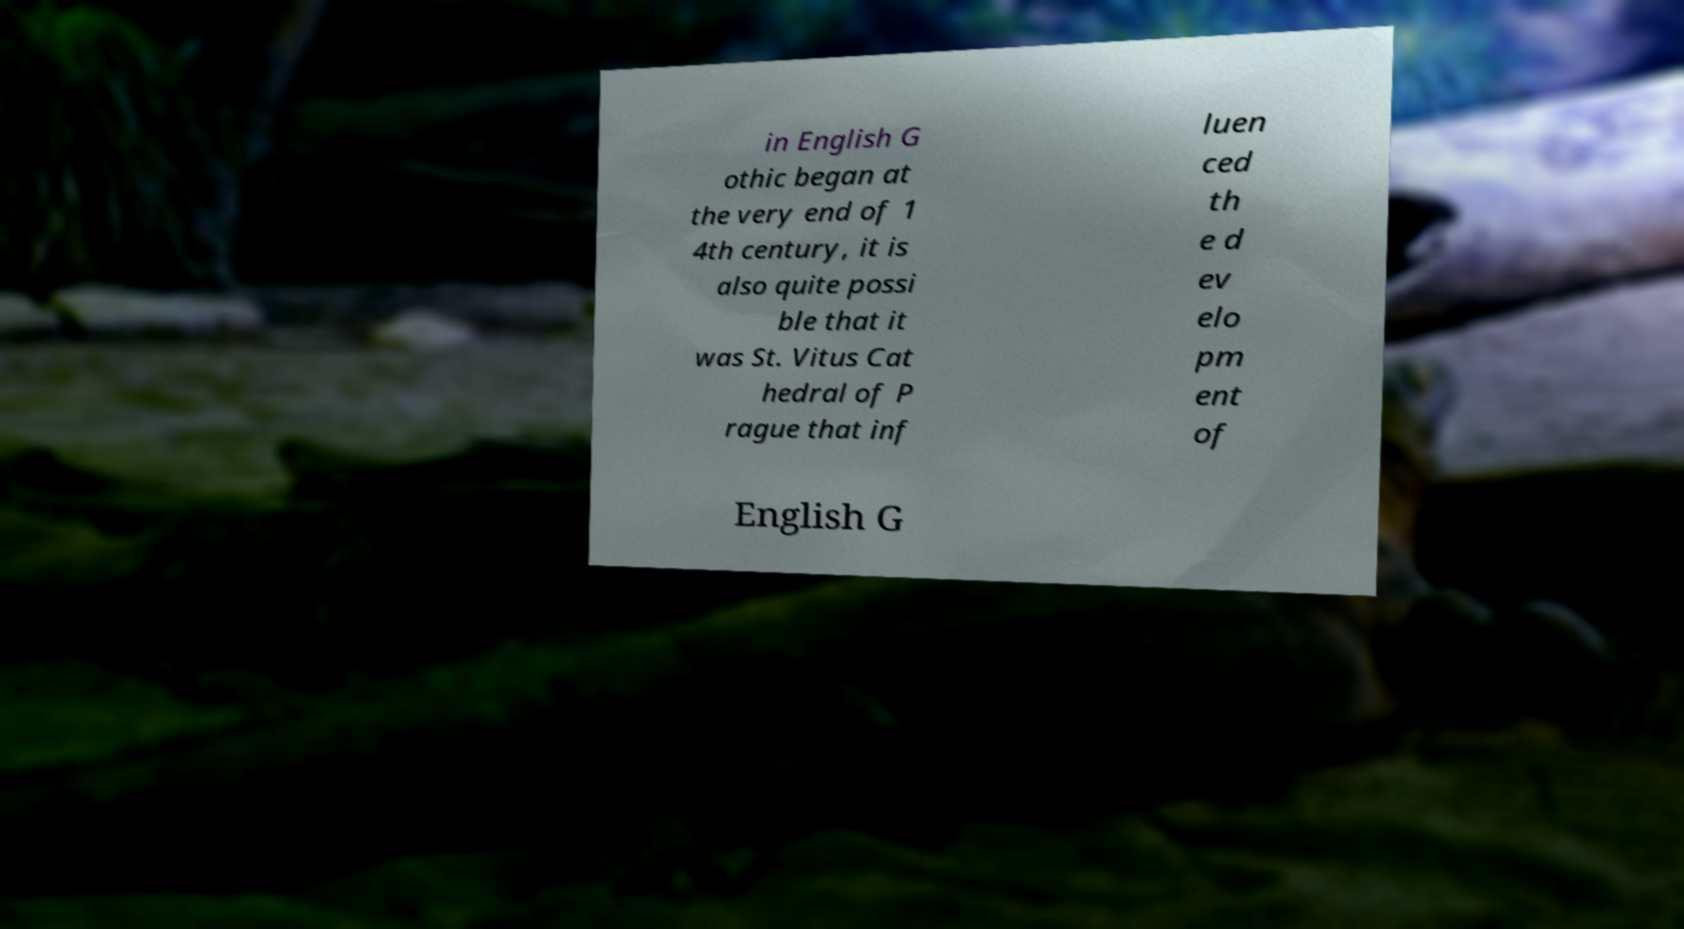Please identify and transcribe the text found in this image. in English G othic began at the very end of 1 4th century, it is also quite possi ble that it was St. Vitus Cat hedral of P rague that inf luen ced th e d ev elo pm ent of English G 